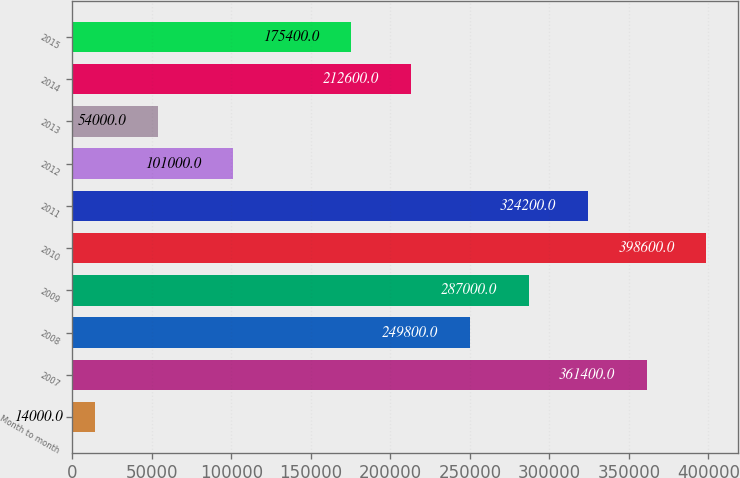Convert chart. <chart><loc_0><loc_0><loc_500><loc_500><bar_chart><fcel>Month to month<fcel>2007<fcel>2008<fcel>2009<fcel>2010<fcel>2011<fcel>2012<fcel>2013<fcel>2014<fcel>2015<nl><fcel>14000<fcel>361400<fcel>249800<fcel>287000<fcel>398600<fcel>324200<fcel>101000<fcel>54000<fcel>212600<fcel>175400<nl></chart> 